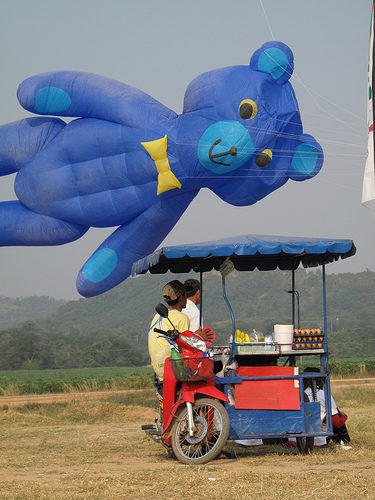<image>
Is the balloon behind the grass? No. The balloon is not behind the grass. From this viewpoint, the balloon appears to be positioned elsewhere in the scene. Is the bear in the sky? Yes. The bear is contained within or inside the sky, showing a containment relationship. 